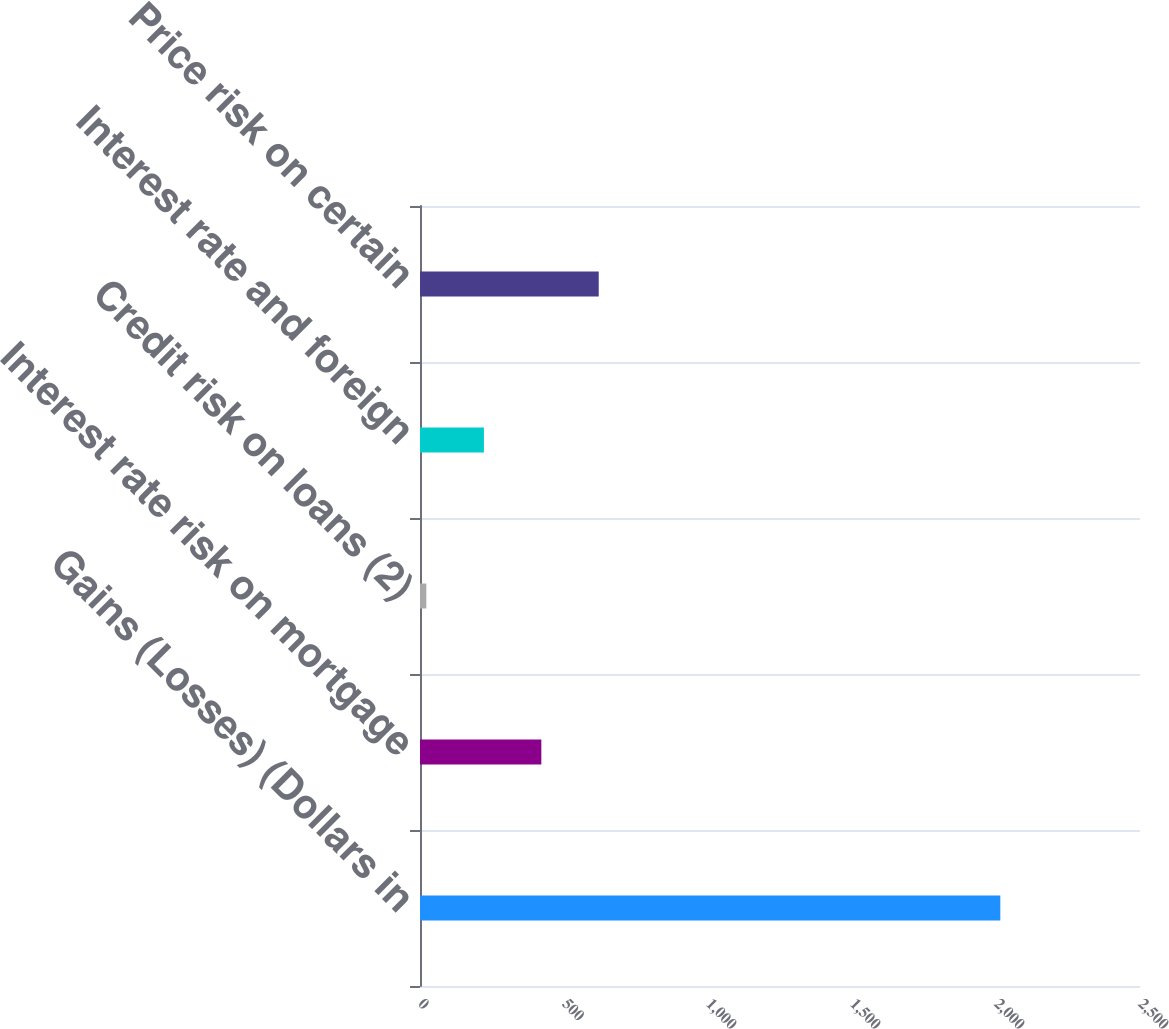<chart> <loc_0><loc_0><loc_500><loc_500><bar_chart><fcel>Gains (Losses) (Dollars in<fcel>Interest rate risk on mortgage<fcel>Credit risk on loans (2)<fcel>Interest rate and foreign<fcel>Price risk on certain<nl><fcel>2015<fcel>421.3<fcel>22<fcel>222<fcel>620.6<nl></chart> 